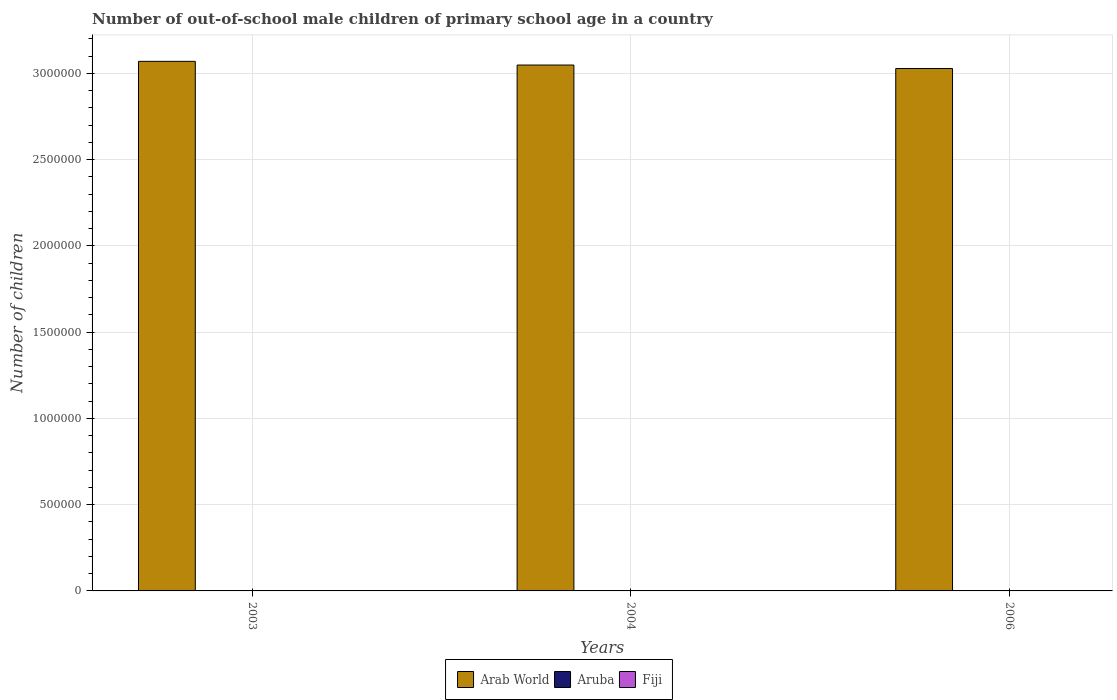How many different coloured bars are there?
Offer a very short reply. 3. How many groups of bars are there?
Provide a short and direct response. 3. Are the number of bars on each tick of the X-axis equal?
Offer a very short reply. Yes. How many bars are there on the 1st tick from the left?
Offer a very short reply. 3. How many bars are there on the 1st tick from the right?
Make the answer very short. 3. In how many cases, is the number of bars for a given year not equal to the number of legend labels?
Offer a very short reply. 0. What is the number of out-of-school male children in Fiji in 2003?
Keep it short and to the point. 957. Across all years, what is the maximum number of out-of-school male children in Arab World?
Your answer should be compact. 3.07e+06. Across all years, what is the minimum number of out-of-school male children in Fiji?
Keep it short and to the point. 525. In which year was the number of out-of-school male children in Aruba minimum?
Your response must be concise. 2006. What is the total number of out-of-school male children in Fiji in the graph?
Your answer should be very brief. 2396. What is the difference between the number of out-of-school male children in Arab World in 2003 and that in 2006?
Make the answer very short. 4.15e+04. What is the difference between the number of out-of-school male children in Aruba in 2006 and the number of out-of-school male children in Arab World in 2004?
Your answer should be very brief. -3.05e+06. What is the average number of out-of-school male children in Arab World per year?
Give a very brief answer. 3.05e+06. In the year 2006, what is the difference between the number of out-of-school male children in Fiji and number of out-of-school male children in Arab World?
Your response must be concise. -3.03e+06. What is the ratio of the number of out-of-school male children in Fiji in 2003 to that in 2004?
Your answer should be compact. 1.82. Is the number of out-of-school male children in Aruba in 2003 less than that in 2004?
Offer a very short reply. No. What is the difference between the highest and the lowest number of out-of-school male children in Aruba?
Ensure brevity in your answer.  198. In how many years, is the number of out-of-school male children in Fiji greater than the average number of out-of-school male children in Fiji taken over all years?
Give a very brief answer. 2. What does the 3rd bar from the left in 2003 represents?
Offer a terse response. Fiji. What does the 3rd bar from the right in 2006 represents?
Keep it short and to the point. Arab World. How many bars are there?
Keep it short and to the point. 9. Are the values on the major ticks of Y-axis written in scientific E-notation?
Give a very brief answer. No. Does the graph contain any zero values?
Your answer should be compact. No. Does the graph contain grids?
Give a very brief answer. Yes. Where does the legend appear in the graph?
Make the answer very short. Bottom center. How are the legend labels stacked?
Keep it short and to the point. Horizontal. What is the title of the graph?
Offer a terse response. Number of out-of-school male children of primary school age in a country. Does "Benin" appear as one of the legend labels in the graph?
Keep it short and to the point. No. What is the label or title of the Y-axis?
Keep it short and to the point. Number of children. What is the Number of children of Arab World in 2003?
Make the answer very short. 3.07e+06. What is the Number of children in Aruba in 2003?
Offer a terse response. 222. What is the Number of children in Fiji in 2003?
Provide a short and direct response. 957. What is the Number of children of Arab World in 2004?
Provide a short and direct response. 3.05e+06. What is the Number of children of Aruba in 2004?
Keep it short and to the point. 163. What is the Number of children of Fiji in 2004?
Provide a succinct answer. 525. What is the Number of children of Arab World in 2006?
Provide a short and direct response. 3.03e+06. What is the Number of children in Aruba in 2006?
Offer a terse response. 24. What is the Number of children of Fiji in 2006?
Ensure brevity in your answer.  914. Across all years, what is the maximum Number of children in Arab World?
Make the answer very short. 3.07e+06. Across all years, what is the maximum Number of children of Aruba?
Your answer should be very brief. 222. Across all years, what is the maximum Number of children in Fiji?
Offer a very short reply. 957. Across all years, what is the minimum Number of children in Arab World?
Your answer should be compact. 3.03e+06. Across all years, what is the minimum Number of children in Aruba?
Offer a terse response. 24. Across all years, what is the minimum Number of children of Fiji?
Give a very brief answer. 525. What is the total Number of children in Arab World in the graph?
Ensure brevity in your answer.  9.15e+06. What is the total Number of children in Aruba in the graph?
Provide a succinct answer. 409. What is the total Number of children in Fiji in the graph?
Keep it short and to the point. 2396. What is the difference between the Number of children of Arab World in 2003 and that in 2004?
Keep it short and to the point. 2.14e+04. What is the difference between the Number of children in Aruba in 2003 and that in 2004?
Provide a short and direct response. 59. What is the difference between the Number of children in Fiji in 2003 and that in 2004?
Your answer should be very brief. 432. What is the difference between the Number of children in Arab World in 2003 and that in 2006?
Your answer should be compact. 4.15e+04. What is the difference between the Number of children of Aruba in 2003 and that in 2006?
Make the answer very short. 198. What is the difference between the Number of children in Fiji in 2003 and that in 2006?
Give a very brief answer. 43. What is the difference between the Number of children of Arab World in 2004 and that in 2006?
Ensure brevity in your answer.  2.01e+04. What is the difference between the Number of children in Aruba in 2004 and that in 2006?
Provide a succinct answer. 139. What is the difference between the Number of children in Fiji in 2004 and that in 2006?
Your answer should be compact. -389. What is the difference between the Number of children in Arab World in 2003 and the Number of children in Aruba in 2004?
Keep it short and to the point. 3.07e+06. What is the difference between the Number of children of Arab World in 2003 and the Number of children of Fiji in 2004?
Offer a very short reply. 3.07e+06. What is the difference between the Number of children in Aruba in 2003 and the Number of children in Fiji in 2004?
Provide a succinct answer. -303. What is the difference between the Number of children of Arab World in 2003 and the Number of children of Aruba in 2006?
Keep it short and to the point. 3.07e+06. What is the difference between the Number of children of Arab World in 2003 and the Number of children of Fiji in 2006?
Your response must be concise. 3.07e+06. What is the difference between the Number of children in Aruba in 2003 and the Number of children in Fiji in 2006?
Make the answer very short. -692. What is the difference between the Number of children in Arab World in 2004 and the Number of children in Aruba in 2006?
Ensure brevity in your answer.  3.05e+06. What is the difference between the Number of children in Arab World in 2004 and the Number of children in Fiji in 2006?
Your response must be concise. 3.05e+06. What is the difference between the Number of children in Aruba in 2004 and the Number of children in Fiji in 2006?
Provide a succinct answer. -751. What is the average Number of children of Arab World per year?
Provide a succinct answer. 3.05e+06. What is the average Number of children of Aruba per year?
Give a very brief answer. 136.33. What is the average Number of children of Fiji per year?
Your answer should be compact. 798.67. In the year 2003, what is the difference between the Number of children in Arab World and Number of children in Aruba?
Your response must be concise. 3.07e+06. In the year 2003, what is the difference between the Number of children of Arab World and Number of children of Fiji?
Your answer should be very brief. 3.07e+06. In the year 2003, what is the difference between the Number of children in Aruba and Number of children in Fiji?
Offer a terse response. -735. In the year 2004, what is the difference between the Number of children of Arab World and Number of children of Aruba?
Offer a very short reply. 3.05e+06. In the year 2004, what is the difference between the Number of children in Arab World and Number of children in Fiji?
Give a very brief answer. 3.05e+06. In the year 2004, what is the difference between the Number of children of Aruba and Number of children of Fiji?
Make the answer very short. -362. In the year 2006, what is the difference between the Number of children of Arab World and Number of children of Aruba?
Your answer should be very brief. 3.03e+06. In the year 2006, what is the difference between the Number of children in Arab World and Number of children in Fiji?
Your answer should be very brief. 3.03e+06. In the year 2006, what is the difference between the Number of children of Aruba and Number of children of Fiji?
Your response must be concise. -890. What is the ratio of the Number of children of Aruba in 2003 to that in 2004?
Offer a very short reply. 1.36. What is the ratio of the Number of children in Fiji in 2003 to that in 2004?
Make the answer very short. 1.82. What is the ratio of the Number of children in Arab World in 2003 to that in 2006?
Provide a short and direct response. 1.01. What is the ratio of the Number of children of Aruba in 2003 to that in 2006?
Provide a succinct answer. 9.25. What is the ratio of the Number of children in Fiji in 2003 to that in 2006?
Keep it short and to the point. 1.05. What is the ratio of the Number of children of Arab World in 2004 to that in 2006?
Offer a terse response. 1.01. What is the ratio of the Number of children of Aruba in 2004 to that in 2006?
Provide a succinct answer. 6.79. What is the ratio of the Number of children of Fiji in 2004 to that in 2006?
Offer a terse response. 0.57. What is the difference between the highest and the second highest Number of children of Arab World?
Your answer should be compact. 2.14e+04. What is the difference between the highest and the second highest Number of children in Aruba?
Offer a terse response. 59. What is the difference between the highest and the lowest Number of children of Arab World?
Provide a succinct answer. 4.15e+04. What is the difference between the highest and the lowest Number of children of Aruba?
Keep it short and to the point. 198. What is the difference between the highest and the lowest Number of children in Fiji?
Give a very brief answer. 432. 